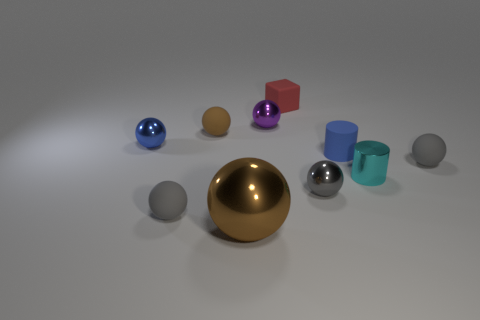How many other things are there of the same material as the small purple ball?
Ensure brevity in your answer.  4. There is a red thing that is the same size as the purple sphere; what is its material?
Provide a short and direct response. Rubber. Does the blue object that is right of the red cube have the same shape as the tiny matte thing behind the small brown matte sphere?
Make the answer very short. No. What shape is the brown matte thing that is the same size as the rubber block?
Provide a succinct answer. Sphere. Does the blue thing that is on the left side of the blue cylinder have the same material as the ball on the right side of the tiny cyan shiny cylinder?
Offer a terse response. No. There is a tiny blue thing in front of the blue ball; is there a gray metal thing on the right side of it?
Your response must be concise. No. There is a cylinder that is made of the same material as the blue ball; what is its color?
Offer a very short reply. Cyan. Are there more tiny yellow cylinders than tiny brown matte spheres?
Your answer should be very brief. No. What number of things are small metallic cylinders in front of the small matte cylinder or tiny red rubber blocks?
Offer a very short reply. 2. Is there a cyan ball of the same size as the cyan metallic cylinder?
Your response must be concise. No. 